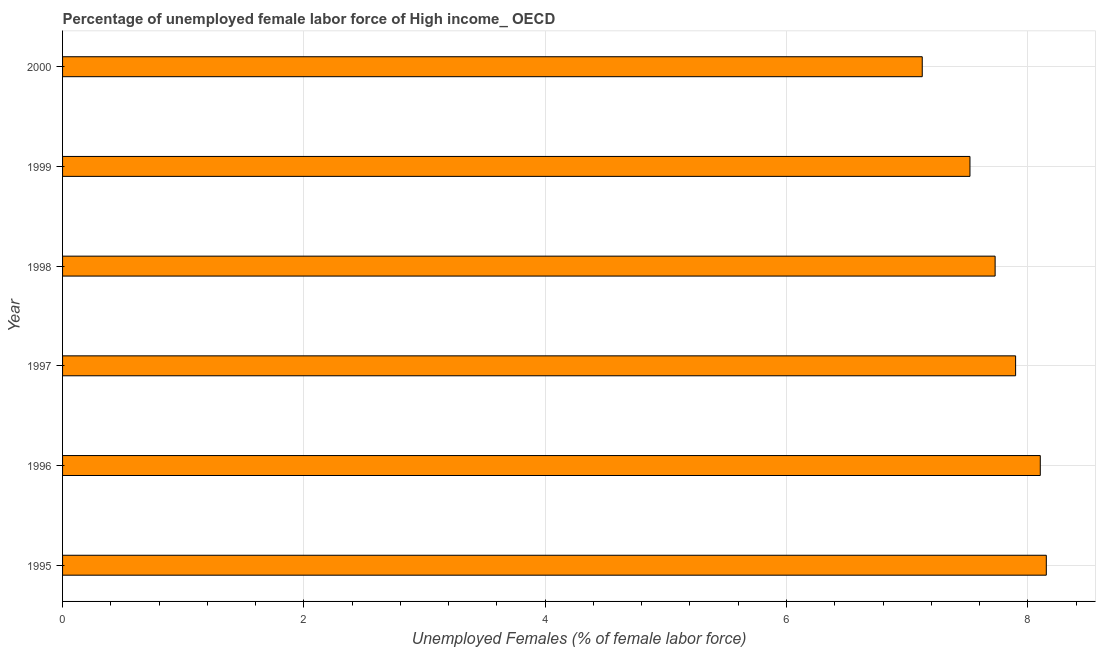Does the graph contain any zero values?
Provide a succinct answer. No. What is the title of the graph?
Offer a terse response. Percentage of unemployed female labor force of High income_ OECD. What is the label or title of the X-axis?
Provide a short and direct response. Unemployed Females (% of female labor force). What is the total unemployed female labour force in 1997?
Offer a very short reply. 7.9. Across all years, what is the maximum total unemployed female labour force?
Offer a terse response. 8.15. Across all years, what is the minimum total unemployed female labour force?
Provide a succinct answer. 7.12. What is the sum of the total unemployed female labour force?
Keep it short and to the point. 46.53. What is the difference between the total unemployed female labour force in 1996 and 2000?
Your response must be concise. 0.98. What is the average total unemployed female labour force per year?
Keep it short and to the point. 7.75. What is the median total unemployed female labour force?
Provide a succinct answer. 7.81. Do a majority of the years between 1999 and 1997 (inclusive) have total unemployed female labour force greater than 2.8 %?
Offer a very short reply. Yes. What is the ratio of the total unemployed female labour force in 1995 to that in 2000?
Make the answer very short. 1.14. What is the difference between the highest and the lowest total unemployed female labour force?
Offer a very short reply. 1.03. In how many years, is the total unemployed female labour force greater than the average total unemployed female labour force taken over all years?
Provide a short and direct response. 3. Are all the bars in the graph horizontal?
Offer a terse response. Yes. What is the Unemployed Females (% of female labor force) of 1995?
Keep it short and to the point. 8.15. What is the Unemployed Females (% of female labor force) of 1996?
Your response must be concise. 8.1. What is the Unemployed Females (% of female labor force) in 1997?
Offer a very short reply. 7.9. What is the Unemployed Females (% of female labor force) of 1998?
Provide a short and direct response. 7.73. What is the Unemployed Females (% of female labor force) of 1999?
Your response must be concise. 7.52. What is the Unemployed Females (% of female labor force) of 2000?
Provide a short and direct response. 7.12. What is the difference between the Unemployed Females (% of female labor force) in 1995 and 1996?
Your response must be concise. 0.05. What is the difference between the Unemployed Females (% of female labor force) in 1995 and 1997?
Ensure brevity in your answer.  0.25. What is the difference between the Unemployed Females (% of female labor force) in 1995 and 1998?
Keep it short and to the point. 0.42. What is the difference between the Unemployed Females (% of female labor force) in 1995 and 1999?
Your answer should be very brief. 0.63. What is the difference between the Unemployed Females (% of female labor force) in 1995 and 2000?
Ensure brevity in your answer.  1.03. What is the difference between the Unemployed Females (% of female labor force) in 1996 and 1997?
Your response must be concise. 0.2. What is the difference between the Unemployed Females (% of female labor force) in 1996 and 1998?
Offer a terse response. 0.37. What is the difference between the Unemployed Females (% of female labor force) in 1996 and 1999?
Your response must be concise. 0.58. What is the difference between the Unemployed Females (% of female labor force) in 1996 and 2000?
Offer a very short reply. 0.98. What is the difference between the Unemployed Females (% of female labor force) in 1997 and 1998?
Make the answer very short. 0.17. What is the difference between the Unemployed Females (% of female labor force) in 1997 and 1999?
Your response must be concise. 0.38. What is the difference between the Unemployed Females (% of female labor force) in 1997 and 2000?
Make the answer very short. 0.77. What is the difference between the Unemployed Females (% of female labor force) in 1998 and 1999?
Your answer should be compact. 0.21. What is the difference between the Unemployed Females (% of female labor force) in 1998 and 2000?
Offer a very short reply. 0.6. What is the difference between the Unemployed Females (% of female labor force) in 1999 and 2000?
Provide a succinct answer. 0.4. What is the ratio of the Unemployed Females (% of female labor force) in 1995 to that in 1996?
Ensure brevity in your answer.  1.01. What is the ratio of the Unemployed Females (% of female labor force) in 1995 to that in 1997?
Your answer should be very brief. 1.03. What is the ratio of the Unemployed Females (% of female labor force) in 1995 to that in 1998?
Provide a short and direct response. 1.05. What is the ratio of the Unemployed Females (% of female labor force) in 1995 to that in 1999?
Make the answer very short. 1.08. What is the ratio of the Unemployed Females (% of female labor force) in 1995 to that in 2000?
Keep it short and to the point. 1.14. What is the ratio of the Unemployed Females (% of female labor force) in 1996 to that in 1997?
Provide a short and direct response. 1.03. What is the ratio of the Unemployed Females (% of female labor force) in 1996 to that in 1998?
Keep it short and to the point. 1.05. What is the ratio of the Unemployed Females (% of female labor force) in 1996 to that in 1999?
Your answer should be very brief. 1.08. What is the ratio of the Unemployed Females (% of female labor force) in 1996 to that in 2000?
Offer a very short reply. 1.14. What is the ratio of the Unemployed Females (% of female labor force) in 1997 to that in 2000?
Provide a short and direct response. 1.11. What is the ratio of the Unemployed Females (% of female labor force) in 1998 to that in 1999?
Provide a succinct answer. 1.03. What is the ratio of the Unemployed Females (% of female labor force) in 1998 to that in 2000?
Ensure brevity in your answer.  1.08. What is the ratio of the Unemployed Females (% of female labor force) in 1999 to that in 2000?
Your answer should be very brief. 1.06. 